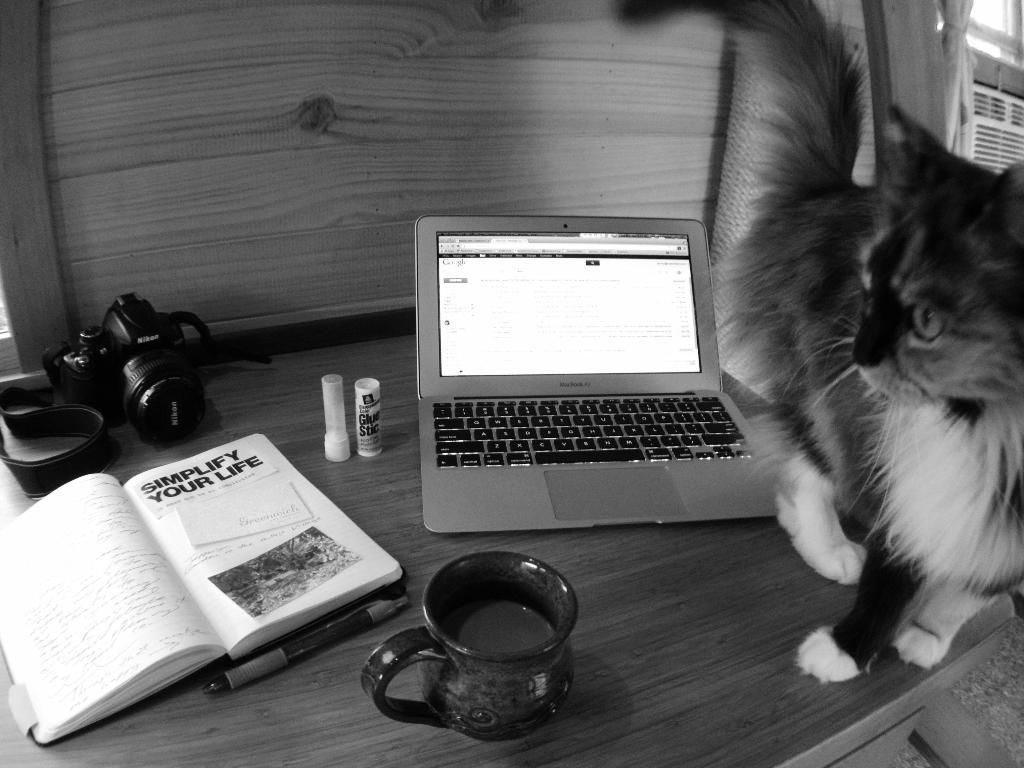What electronic device is on the table in the image? There is a laptop on the table in the image. What other objects can be seen on the table? There is a camera, a book, a cup, and a cat on the table. What might the cat be doing on the table? The cat's actions are not specified in the image, but it is likely resting or observing its surroundings. What type of beverage might be in the cup? The contents of the cup are not specified in the image, so it is impossible to determine the type of beverage. What type of creature is providing shade for the cat in the image? There is no creature providing shade for the cat in the image; the cat is on the table without any apparent shade. 